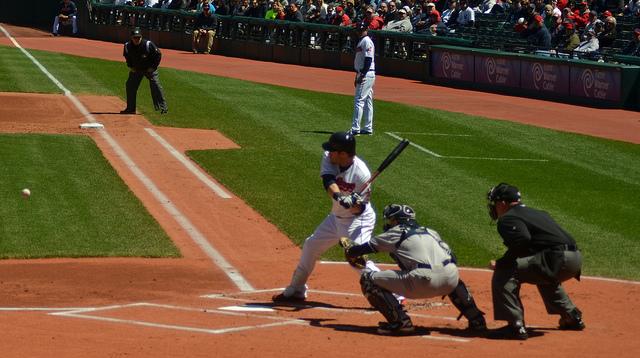Is the player ready to hit a ball?
Concise answer only. Yes. Is the grass maintained?
Write a very short answer. Yes. Is this a football game?
Answer briefly. No. 